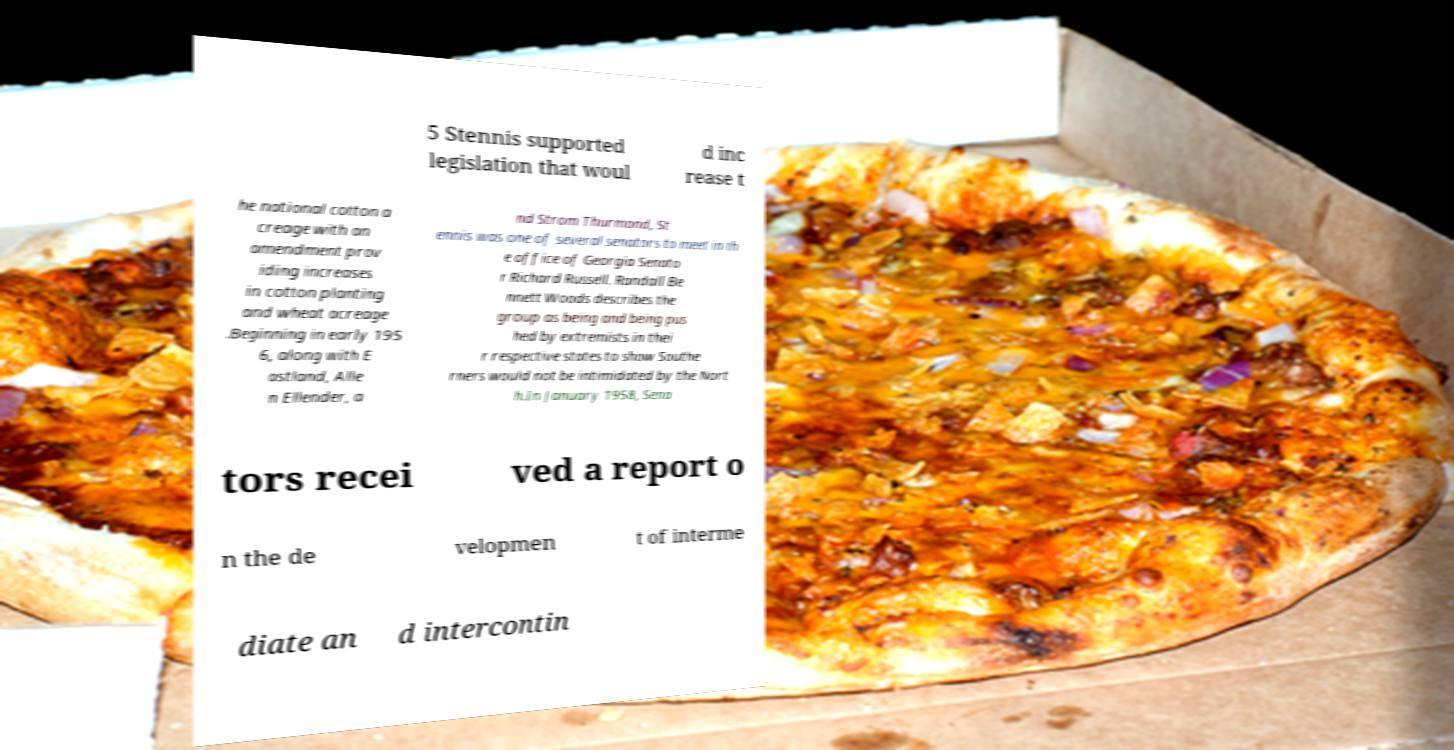Could you assist in decoding the text presented in this image and type it out clearly? 5 Stennis supported legislation that woul d inc rease t he national cotton a creage with an amendment prov iding increases in cotton planting and wheat acreage .Beginning in early 195 6, along with E astland, Alle n Ellender, a nd Strom Thurmond, St ennis was one of several senators to meet in th e office of Georgia Senato r Richard Russell. Randall Be nnett Woods describes the group as being and being pus hed by extremists in thei r respective states to show Southe rners would not be intimidated by the Nort h.In January 1958, Sena tors recei ved a report o n the de velopmen t of interme diate an d intercontin 